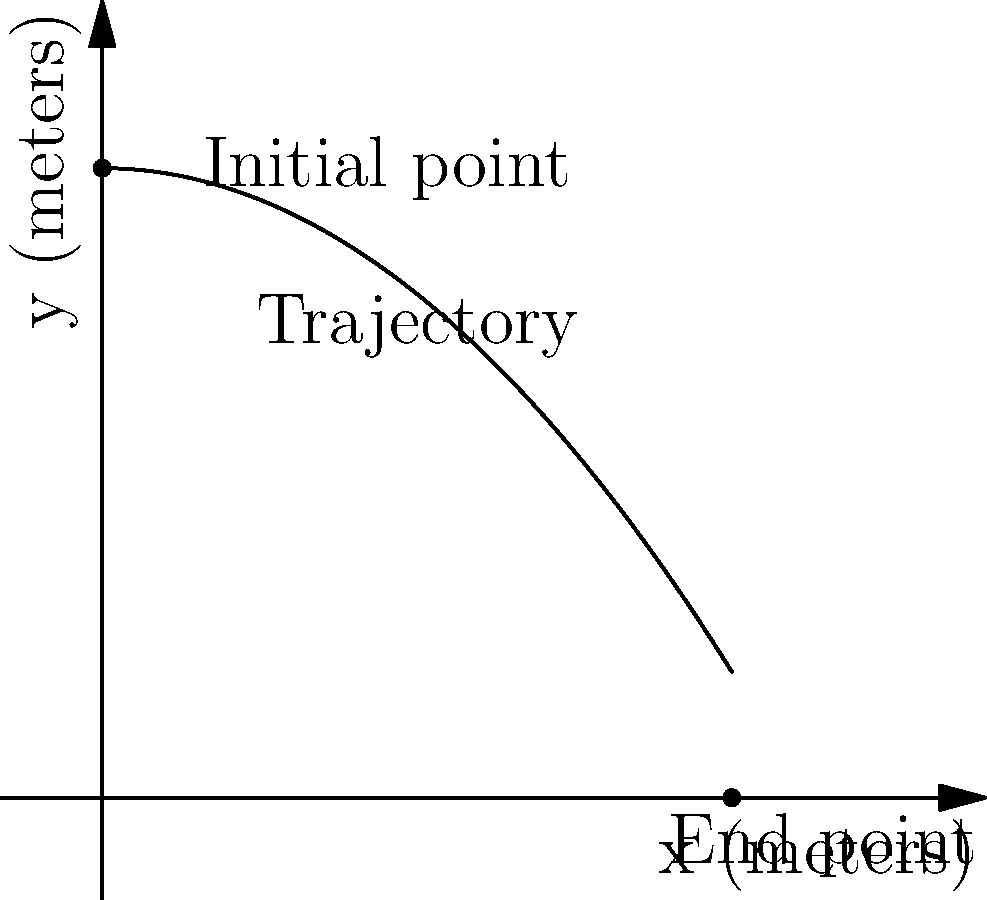During a hurling match, Shane O'Brien hits a puck with an initial height of 4 meters. The trajectory of the puck can be modeled by the function $f(x)=4-0.2x^2$, where $x$ is the horizontal distance in meters and $f(x)$ is the height in meters. Calculate the area under the curve from the initial point to where the puck hits the ground. To find the area under the curve, we need to integrate the function from the initial point to where the puck hits the ground. Let's approach this step-by-step:

1) First, we need to find where the puck hits the ground. This occurs when $f(x) = 0$:
   $0 = 4 - 0.2x^2$
   $0.2x^2 = 4$
   $x^2 = 20$
   $x = \sqrt{20} = 2\sqrt{5} \approx 4.47$ meters

2) Now we can set up our integral:
   Area = $\int_0^{2\sqrt{5}} (4-0.2x^2) dx$

3) Let's integrate:
   $\int_0^{2\sqrt{5}} (4-0.2x^2) dx = [4x - \frac{0.2x^3}{3}]_0^{2\sqrt{5}}$

4) Evaluate the integral:
   $= (4(2\sqrt{5}) - \frac{0.2(2\sqrt{5})^3}{3}) - (4(0) - \frac{0.2(0)^3}{3})$
   $= 8\sqrt{5} - \frac{0.2(8\sqrt{125})}{3}$
   $= 8\sqrt{5} - \frac{8\sqrt{5}}{3}$
   $= \frac{24\sqrt{5} - 8\sqrt{5}}{3}$
   $= \frac{16\sqrt{5}}{3}$

5) This can be simplified to:
   $\frac{16\sqrt{5}}{3} \approx 11.95$ square meters
Answer: $\frac{16\sqrt{5}}{3}$ square meters 